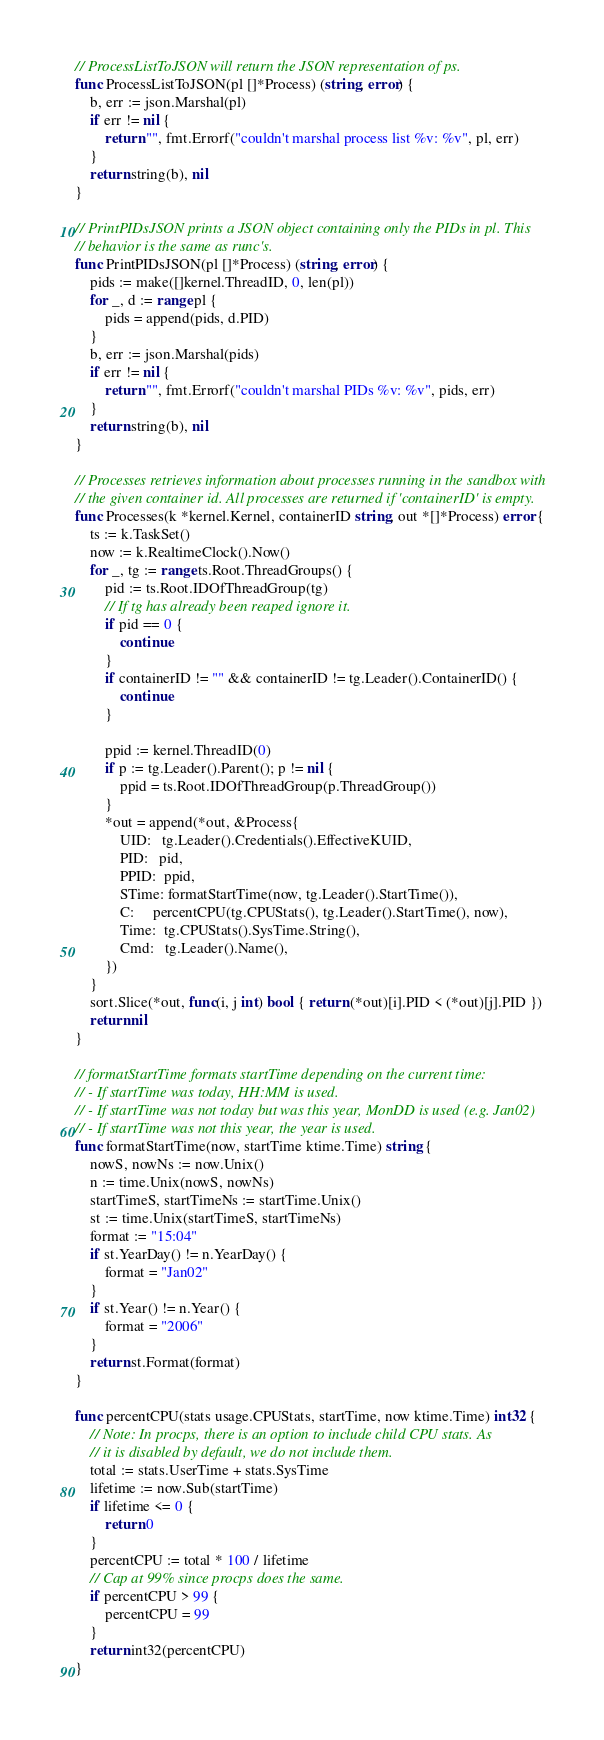<code> <loc_0><loc_0><loc_500><loc_500><_Go_>// ProcessListToJSON will return the JSON representation of ps.
func ProcessListToJSON(pl []*Process) (string, error) {
	b, err := json.Marshal(pl)
	if err != nil {
		return "", fmt.Errorf("couldn't marshal process list %v: %v", pl, err)
	}
	return string(b), nil
}

// PrintPIDsJSON prints a JSON object containing only the PIDs in pl. This
// behavior is the same as runc's.
func PrintPIDsJSON(pl []*Process) (string, error) {
	pids := make([]kernel.ThreadID, 0, len(pl))
	for _, d := range pl {
		pids = append(pids, d.PID)
	}
	b, err := json.Marshal(pids)
	if err != nil {
		return "", fmt.Errorf("couldn't marshal PIDs %v: %v", pids, err)
	}
	return string(b), nil
}

// Processes retrieves information about processes running in the sandbox with
// the given container id. All processes are returned if 'containerID' is empty.
func Processes(k *kernel.Kernel, containerID string, out *[]*Process) error {
	ts := k.TaskSet()
	now := k.RealtimeClock().Now()
	for _, tg := range ts.Root.ThreadGroups() {
		pid := ts.Root.IDOfThreadGroup(tg)
		// If tg has already been reaped ignore it.
		if pid == 0 {
			continue
		}
		if containerID != "" && containerID != tg.Leader().ContainerID() {
			continue
		}

		ppid := kernel.ThreadID(0)
		if p := tg.Leader().Parent(); p != nil {
			ppid = ts.Root.IDOfThreadGroup(p.ThreadGroup())
		}
		*out = append(*out, &Process{
			UID:   tg.Leader().Credentials().EffectiveKUID,
			PID:   pid,
			PPID:  ppid,
			STime: formatStartTime(now, tg.Leader().StartTime()),
			C:     percentCPU(tg.CPUStats(), tg.Leader().StartTime(), now),
			Time:  tg.CPUStats().SysTime.String(),
			Cmd:   tg.Leader().Name(),
		})
	}
	sort.Slice(*out, func(i, j int) bool { return (*out)[i].PID < (*out)[j].PID })
	return nil
}

// formatStartTime formats startTime depending on the current time:
// - If startTime was today, HH:MM is used.
// - If startTime was not today but was this year, MonDD is used (e.g. Jan02)
// - If startTime was not this year, the year is used.
func formatStartTime(now, startTime ktime.Time) string {
	nowS, nowNs := now.Unix()
	n := time.Unix(nowS, nowNs)
	startTimeS, startTimeNs := startTime.Unix()
	st := time.Unix(startTimeS, startTimeNs)
	format := "15:04"
	if st.YearDay() != n.YearDay() {
		format = "Jan02"
	}
	if st.Year() != n.Year() {
		format = "2006"
	}
	return st.Format(format)
}

func percentCPU(stats usage.CPUStats, startTime, now ktime.Time) int32 {
	// Note: In procps, there is an option to include child CPU stats. As
	// it is disabled by default, we do not include them.
	total := stats.UserTime + stats.SysTime
	lifetime := now.Sub(startTime)
	if lifetime <= 0 {
		return 0
	}
	percentCPU := total * 100 / lifetime
	// Cap at 99% since procps does the same.
	if percentCPU > 99 {
		percentCPU = 99
	}
	return int32(percentCPU)
}
</code> 